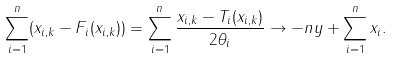<formula> <loc_0><loc_0><loc_500><loc_500>\sum _ { i = 1 } ^ { n } ( x _ { i , k } - F _ { i } ( x _ { i , k } ) ) = \sum _ { i = 1 } ^ { n } \frac { x _ { i , k } - T _ { i } ( x _ { i , k } ) } { 2 \theta _ { i } } \to - n y + \sum _ { i = 1 } ^ { n } x _ { i } .</formula> 